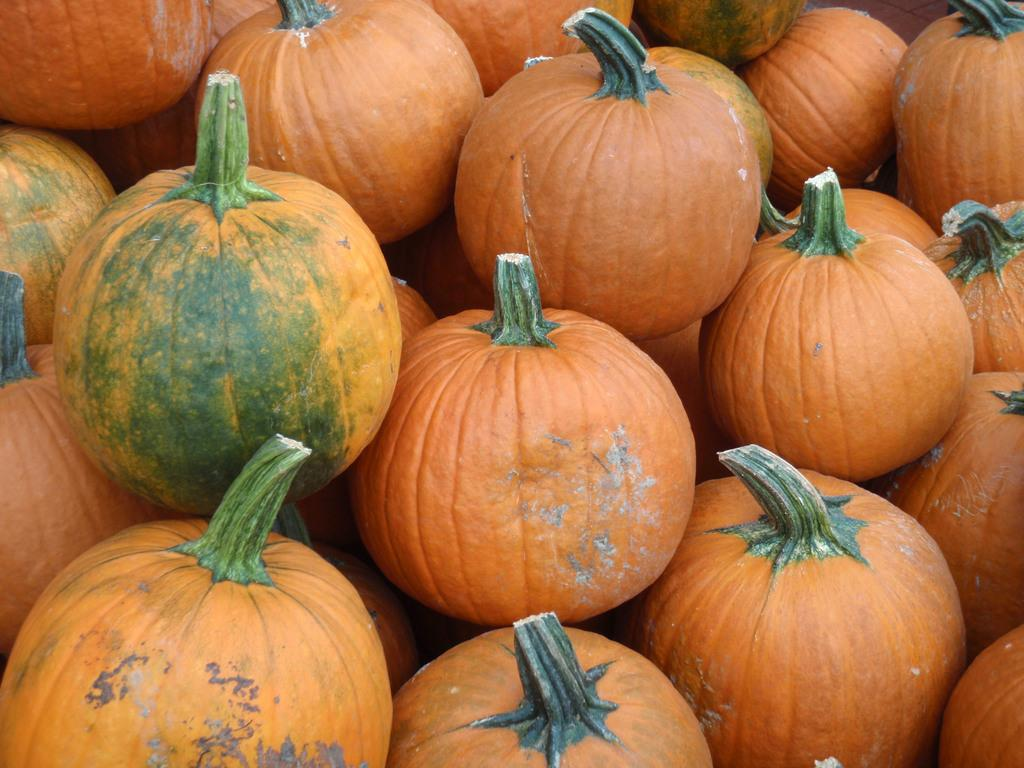What type of objects are present in large quantities in the image? There are many pumpkins in the image. What colors can be seen on the pumpkins in the image? The pumpkins are in orange and green colors. Can you make an educated guess about the location where the image might have been taken? The image might have been taken in a market. What type of steel objects can be seen in the image? There is no steel object present in the image; it features pumpkins in orange and green colors. How many trees are visible in the image? There are no trees visible in the image; it features pumpkins in a market-like setting. 